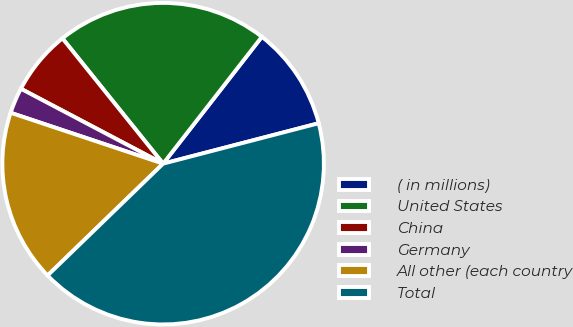Convert chart to OTSL. <chart><loc_0><loc_0><loc_500><loc_500><pie_chart><fcel>( in millions)<fcel>United States<fcel>China<fcel>Germany<fcel>All other (each country<fcel>Total<nl><fcel>10.43%<fcel>21.3%<fcel>6.51%<fcel>2.59%<fcel>17.37%<fcel>41.81%<nl></chart> 